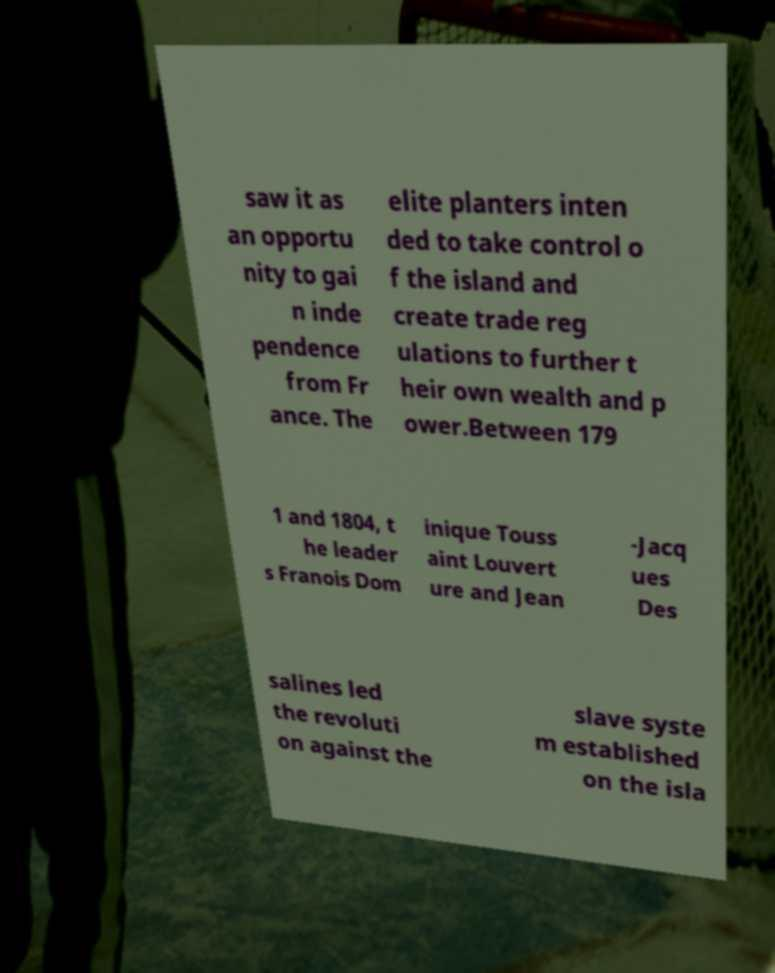Can you accurately transcribe the text from the provided image for me? saw it as an opportu nity to gai n inde pendence from Fr ance. The elite planters inten ded to take control o f the island and create trade reg ulations to further t heir own wealth and p ower.Between 179 1 and 1804, t he leader s Franois Dom inique Touss aint Louvert ure and Jean -Jacq ues Des salines led the revoluti on against the slave syste m established on the isla 